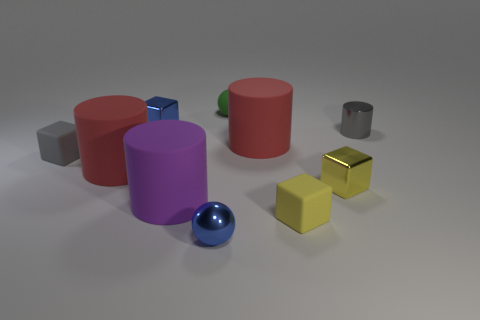Subtract all cylinders. How many objects are left? 6 Subtract all big red metallic objects. Subtract all green balls. How many objects are left? 9 Add 5 rubber cylinders. How many rubber cylinders are left? 8 Add 2 small blue blocks. How many small blue blocks exist? 3 Subtract 1 blue blocks. How many objects are left? 9 